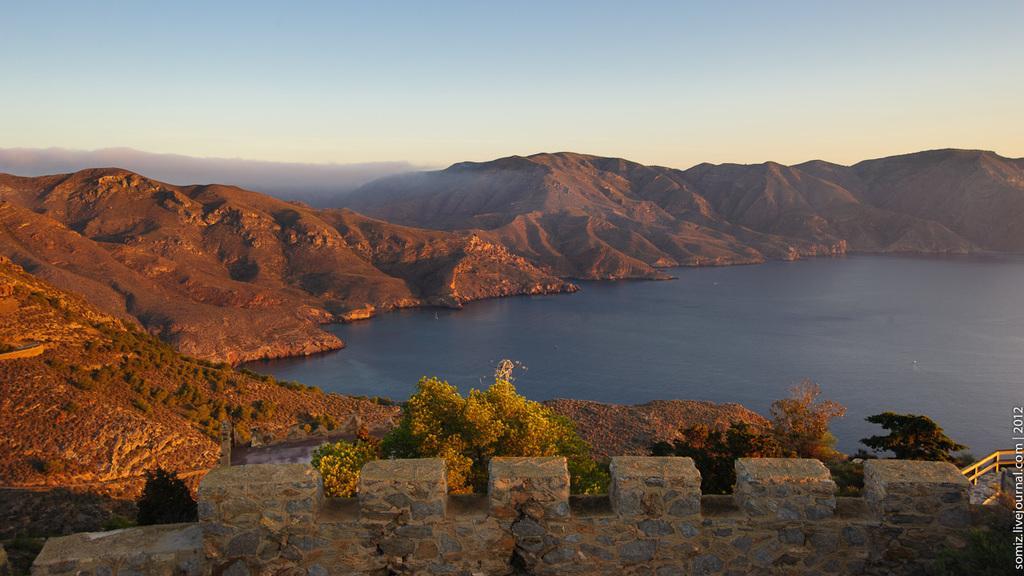In one or two sentences, can you explain what this image depicts? At the bottom of the image there is a wall and a railing, in front of that, there are trees, river, mountains and the sky. 